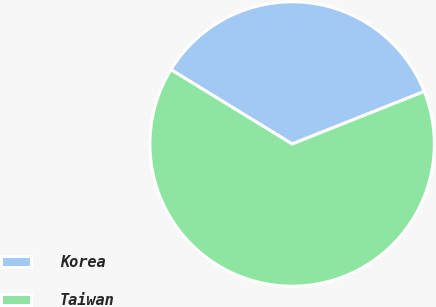<chart> <loc_0><loc_0><loc_500><loc_500><pie_chart><fcel>Korea<fcel>Taiwan<nl><fcel>35.22%<fcel>64.78%<nl></chart> 